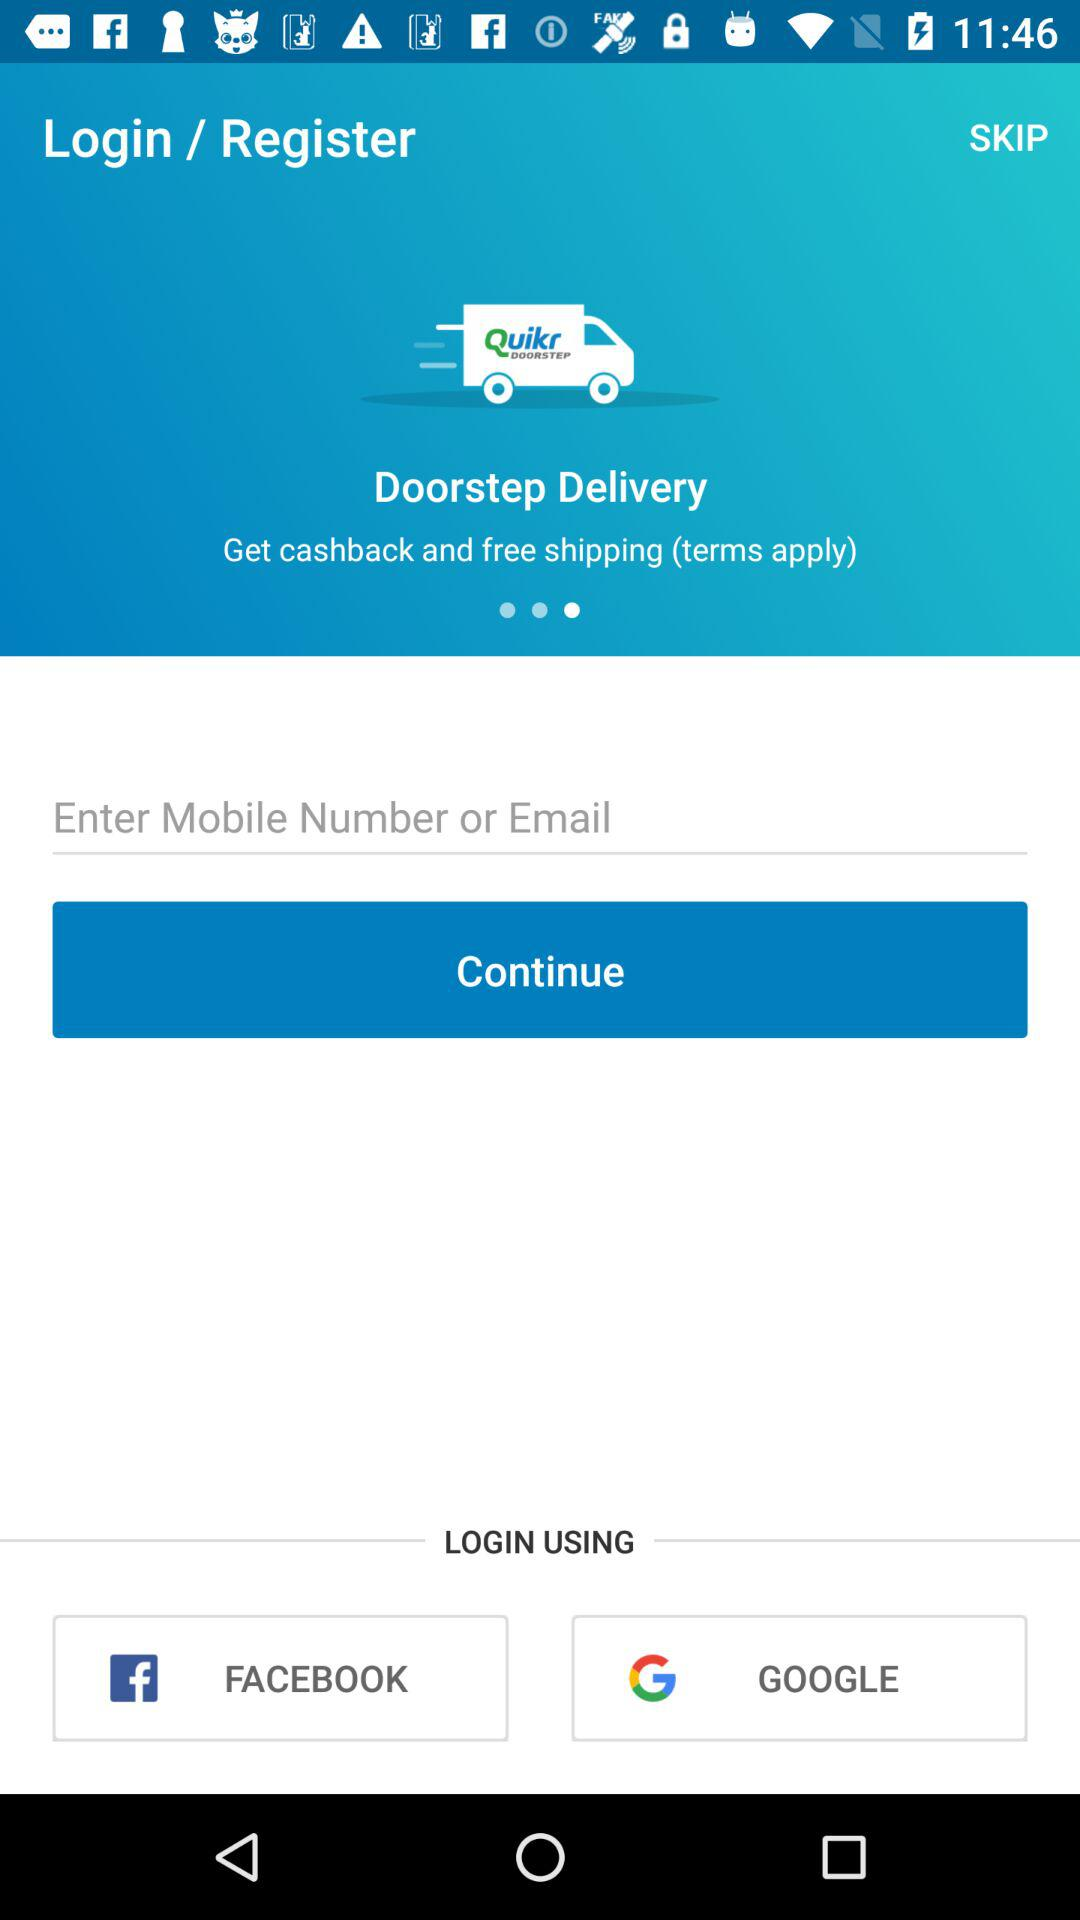What applications can be used for login? The applications are "FACEBOOK" and "GOOGLE". 